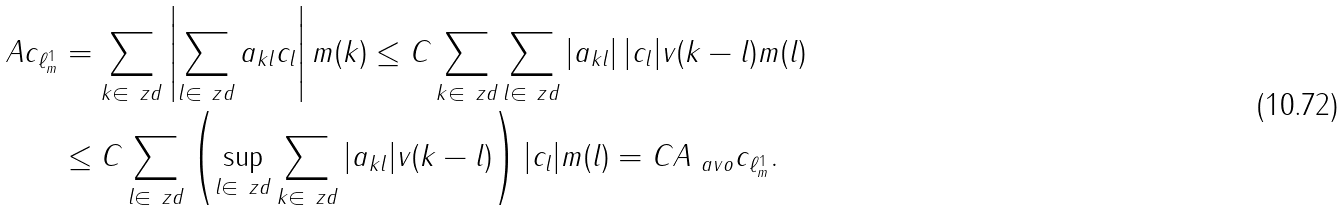Convert formula to latex. <formula><loc_0><loc_0><loc_500><loc_500>\| A c \| _ { \ell ^ { 1 } _ { m } } & = \sum _ { k \in \ z d } \left | \sum _ { l \in \ z d } a _ { k l } c _ { l } \right | m ( k ) \leq C \sum _ { k \in \ z d } \sum _ { l \in \ z d } | a _ { k l } | \, | c _ { l } | v ( k - l ) m ( l ) \\ & \leq C \sum _ { l \in \ z d } \left ( \sup _ { l \in \ z d } \sum _ { k \in \ z d } | a _ { k l } | v ( k - l ) \right ) | c _ { l } | m ( l ) = C \| A \| _ { \ a v o } \| c \| _ { \ell ^ { 1 } _ { m } } .</formula> 